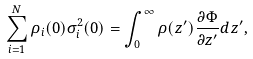<formula> <loc_0><loc_0><loc_500><loc_500>\sum _ { i = 1 } ^ { N } \rho _ { i } ( 0 ) \sigma _ { i } ^ { 2 } ( 0 ) = \int _ { 0 } ^ { \infty } \rho ( z ^ { \prime } ) \frac { \partial \Phi } { \partial z ^ { \prime } } d z ^ { \prime } ,</formula> 